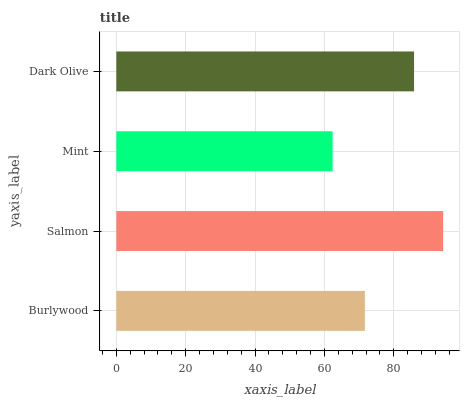Is Mint the minimum?
Answer yes or no. Yes. Is Salmon the maximum?
Answer yes or no. Yes. Is Salmon the minimum?
Answer yes or no. No. Is Mint the maximum?
Answer yes or no. No. Is Salmon greater than Mint?
Answer yes or no. Yes. Is Mint less than Salmon?
Answer yes or no. Yes. Is Mint greater than Salmon?
Answer yes or no. No. Is Salmon less than Mint?
Answer yes or no. No. Is Dark Olive the high median?
Answer yes or no. Yes. Is Burlywood the low median?
Answer yes or no. Yes. Is Mint the high median?
Answer yes or no. No. Is Dark Olive the low median?
Answer yes or no. No. 